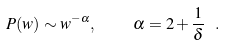<formula> <loc_0><loc_0><loc_500><loc_500>P ( w ) \sim w ^ { - \alpha } , \quad \alpha = 2 + \frac { 1 } { \delta } \ .</formula> 